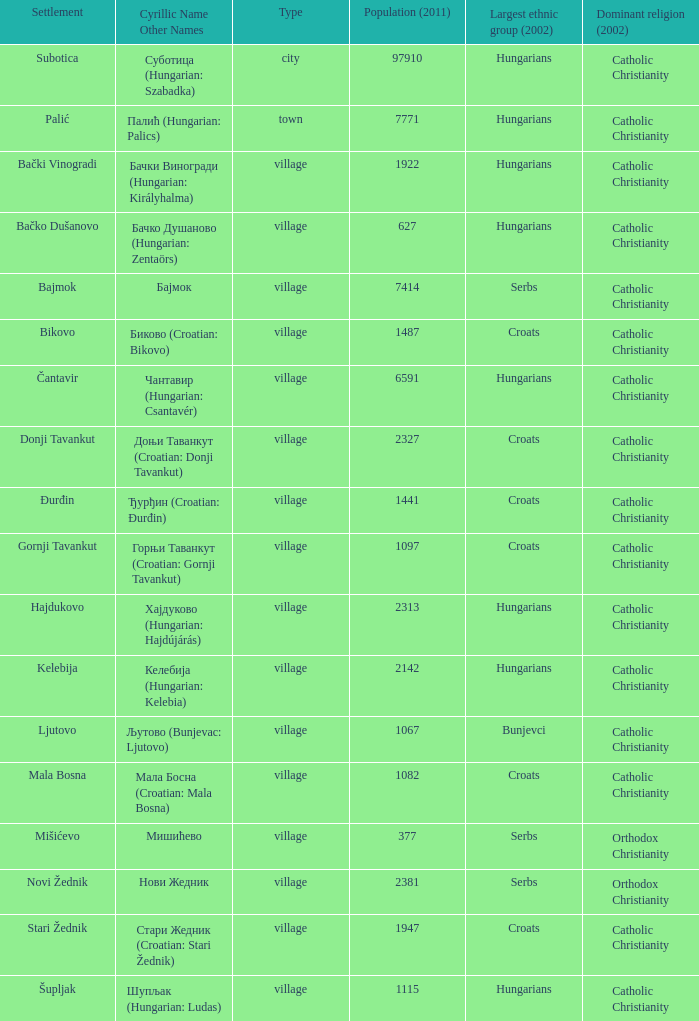How many settlements are named ђурђин (croatian: đurđin)? 1.0. 